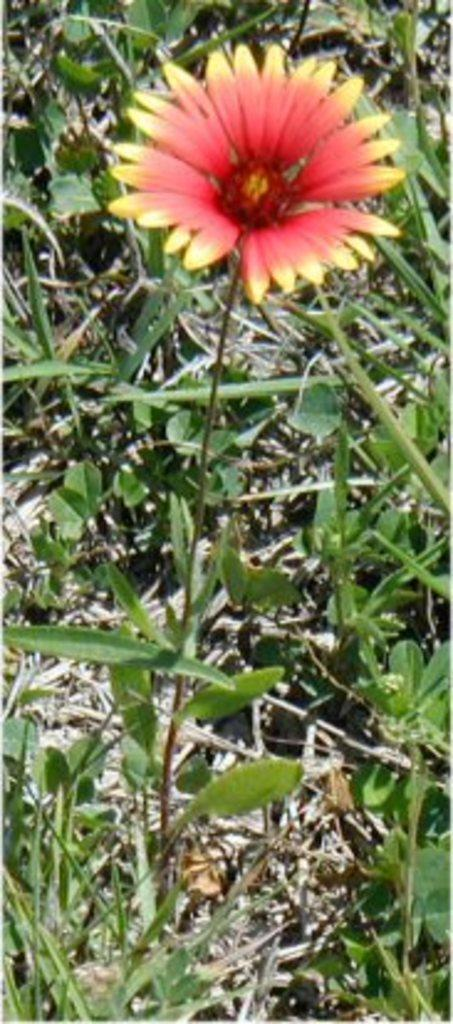What is the main subject of the image? There is a flower in the image. What type of vegetation can be seen in the background of the image? There is grass visible in the background of the image. What type of berry is growing on the flower in the image? There is no berry growing on the flower in the image. Can you see a van or horn in the image? There is no van or horn present in the image. 